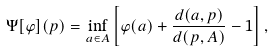<formula> <loc_0><loc_0><loc_500><loc_500>\Psi [ \varphi ] ( p ) = \inf _ { a \in A } \left [ \varphi ( a ) + \frac { d ( a , p ) } { d ( p , A ) } - 1 \right ] ,</formula> 